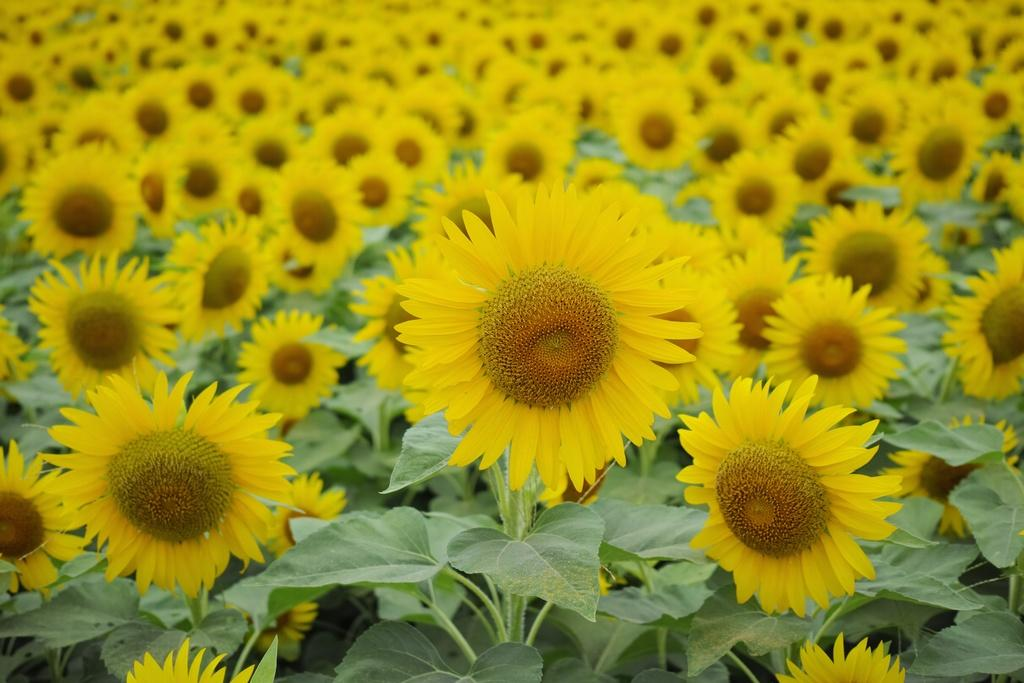What type of flowers are in the image? There are sunflowers in the image. What color are the sunflowers? The sunflowers are yellow. What other part of the sunflower can be seen in the image? There are green leaves in the image. What type of haircut do the sunflowers have in the image? The sunflowers do not have a haircut, as they are plants and not people. 